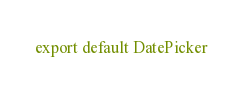Convert code to text. <code><loc_0><loc_0><loc_500><loc_500><_JavaScript_>export default DatePicker


</code> 